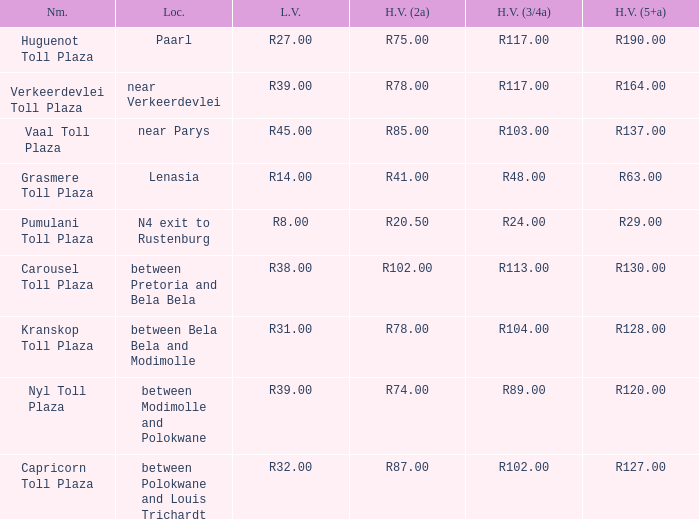What is the charge for heavy vehicles equipped with 3/4 axles at the verkeerdevlei toll plaza? R117.00. 